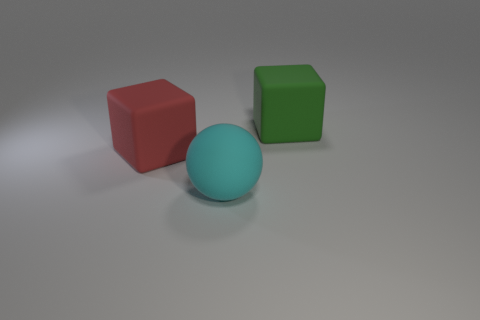Subtract all red blocks. How many blocks are left? 1 Add 2 large rubber objects. How many objects exist? 5 Subtract all blocks. How many objects are left? 1 Add 2 red things. How many red things are left? 3 Add 3 cyan spheres. How many cyan spheres exist? 4 Subtract 0 yellow blocks. How many objects are left? 3 Subtract all gray spheres. Subtract all green cylinders. How many spheres are left? 1 Subtract all small cyan rubber things. Subtract all red matte blocks. How many objects are left? 2 